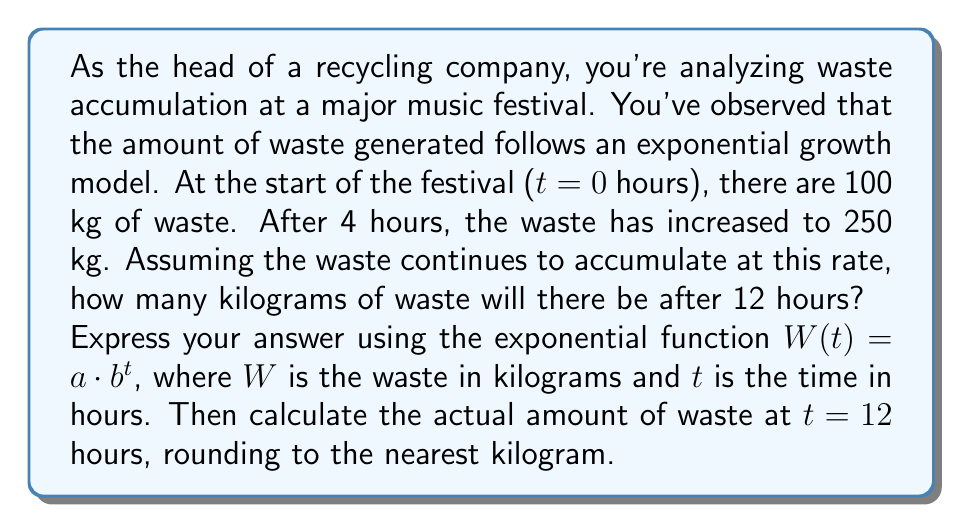Can you solve this math problem? To solve this problem, we need to determine the exponential function that models the waste accumulation, then use it to predict the amount of waste after 12 hours.

Step 1: Set up the exponential function
Let $W(t) = a \cdot b^t$, where:
- $W(t)$ is the amount of waste in kg at time $t$
- $a$ is the initial amount of waste
- $b$ is the growth factor
- $t$ is the time in hours

Step 2: Use the given information to create a system of equations
At $t = 0$: $W(0) = a \cdot b^0 = 100$, so $a = 100$
At $t = 4$: $W(4) = 100 \cdot b^4 = 250$

Step 3: Solve for $b$
$$100 \cdot b^4 = 250$$
$$b^4 = \frac{250}{100} = 2.5$$
$$b = \sqrt[4]{2.5} \approx 1.2585$$

Step 4: Write the complete exponential function
$$W(t) = 100 \cdot (1.2585)^t$$

Step 5: Calculate the amount of waste at $t = 12$ hours
$$W(12) = 100 \cdot (1.2585)^{12} \approx 1559.36 \text{ kg}$$

Rounding to the nearest kilogram: 1559 kg
Answer: The exponential function modeling waste accumulation is:
$$W(t) = 100 \cdot (1.2585)^t$$

After 12 hours, there will be approximately 1559 kg of waste. 